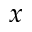Convert formula to latex. <formula><loc_0><loc_0><loc_500><loc_500>x</formula> 